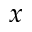Convert formula to latex. <formula><loc_0><loc_0><loc_500><loc_500>x</formula> 